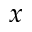Convert formula to latex. <formula><loc_0><loc_0><loc_500><loc_500>x</formula> 